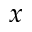Convert formula to latex. <formula><loc_0><loc_0><loc_500><loc_500>x</formula> 